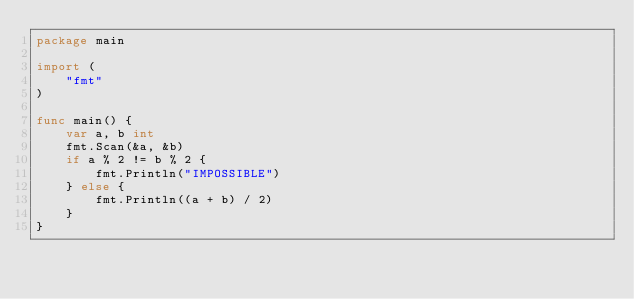<code> <loc_0><loc_0><loc_500><loc_500><_Go_>package main

import (
	"fmt"
)

func main() {
	var a, b int
	fmt.Scan(&a, &b)
	if a % 2 != b % 2 {
		fmt.Println("IMPOSSIBLE")
	} else {
		fmt.Println((a + b) / 2)
	}
}
</code> 